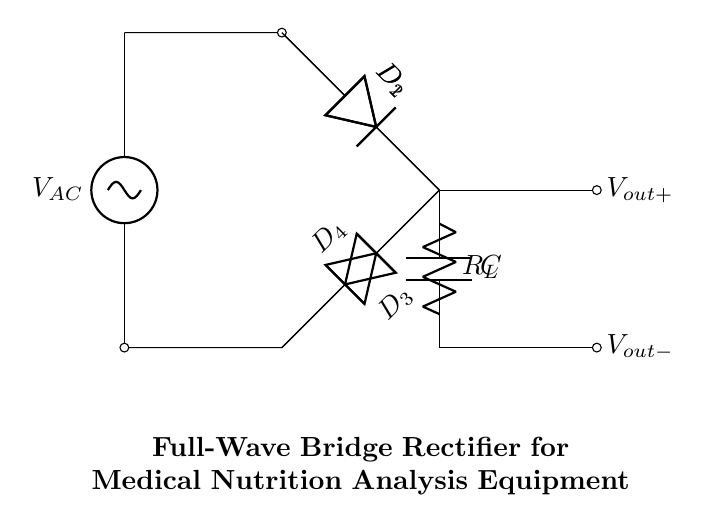What is the main function of this circuit? The main function of this circuit is to convert alternating current to direct current, which is essential for powering electronic devices. This is inferred from the presence of the bridge rectifier, which is specifically designed for this purpose.
Answer: Convert alternating current to direct current How many diodes are used in this rectifier circuit? The circuit diagram shows a total of four diodes arranged in a bridge configuration. Each diode is labeled D1, D2, D3, and D4, indicating their presence.
Answer: Four What is connected to the output of the rectifier? The output of the rectifier connects to a load resistor and a capacitor, crucial for filtering the output voltage. This can be deduced from the connections leading from the bridge rectifier to the components marked R_L and C.
Answer: Load resistor and capacitor What is the purpose of the capacitor in this circuit? The capacitor's purpose in this circuit is to smooth the output voltage by reducing voltage ripple after rectification. This is based on the typical role of capacitors in power supply circuits, especially following rectification.
Answer: Smooth output voltage What type of circuit configuration is used in this rectifier? The circuit configuration used here is a full-wave bridge rectifier, as indicated by the arrangement of the four diodes. This specific arrangement allows current to flow in both directions, converting the full AC waveform to DC.
Answer: Full-wave bridge rectifier What would happen if one diode failed? If one diode in the bridge rectifier fails, the circuit would still function but only half of the AC waveform would be used for rectification, resulting in reduced output voltage. This can be inferred from the role of diodes in conducting during alternating cycles.
Answer: Reduced output voltage 